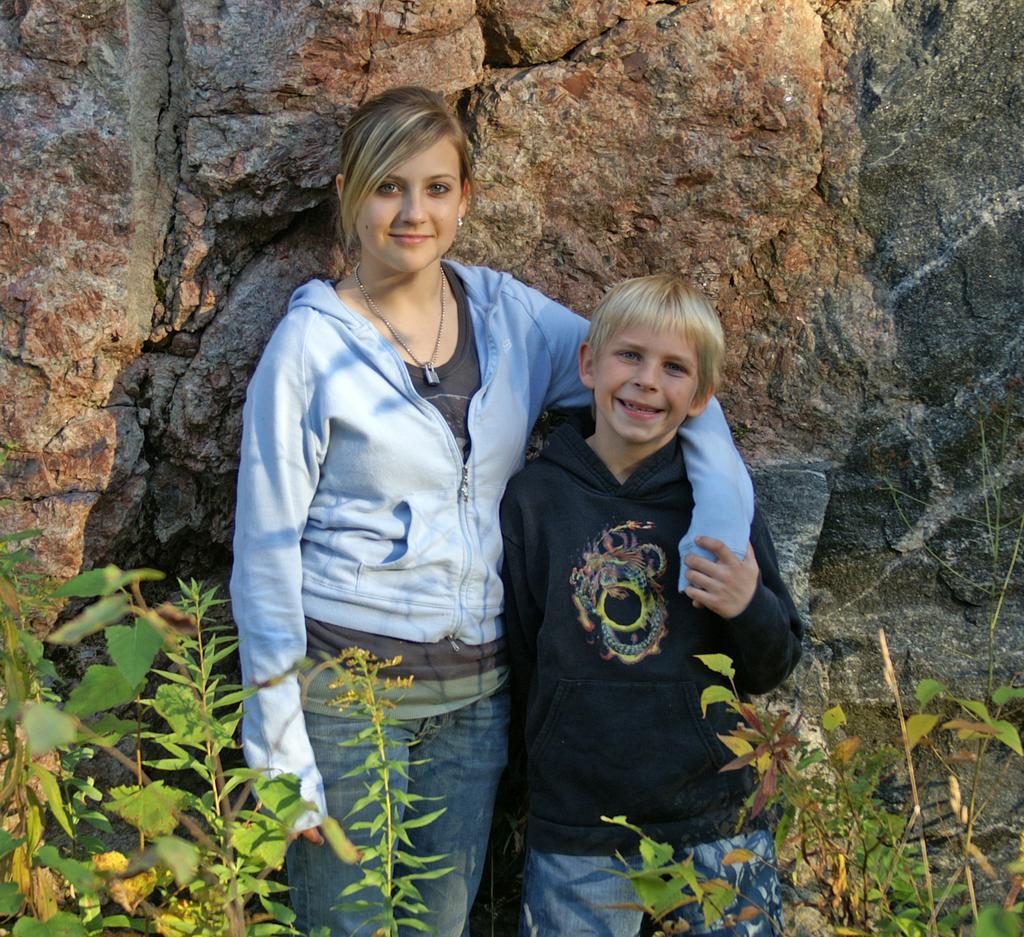Describe this image in one or two sentences. In this image there is a woman and a boy standing. They are smiling. Behind them there are rocks. On the either sides of the image there are plants. 